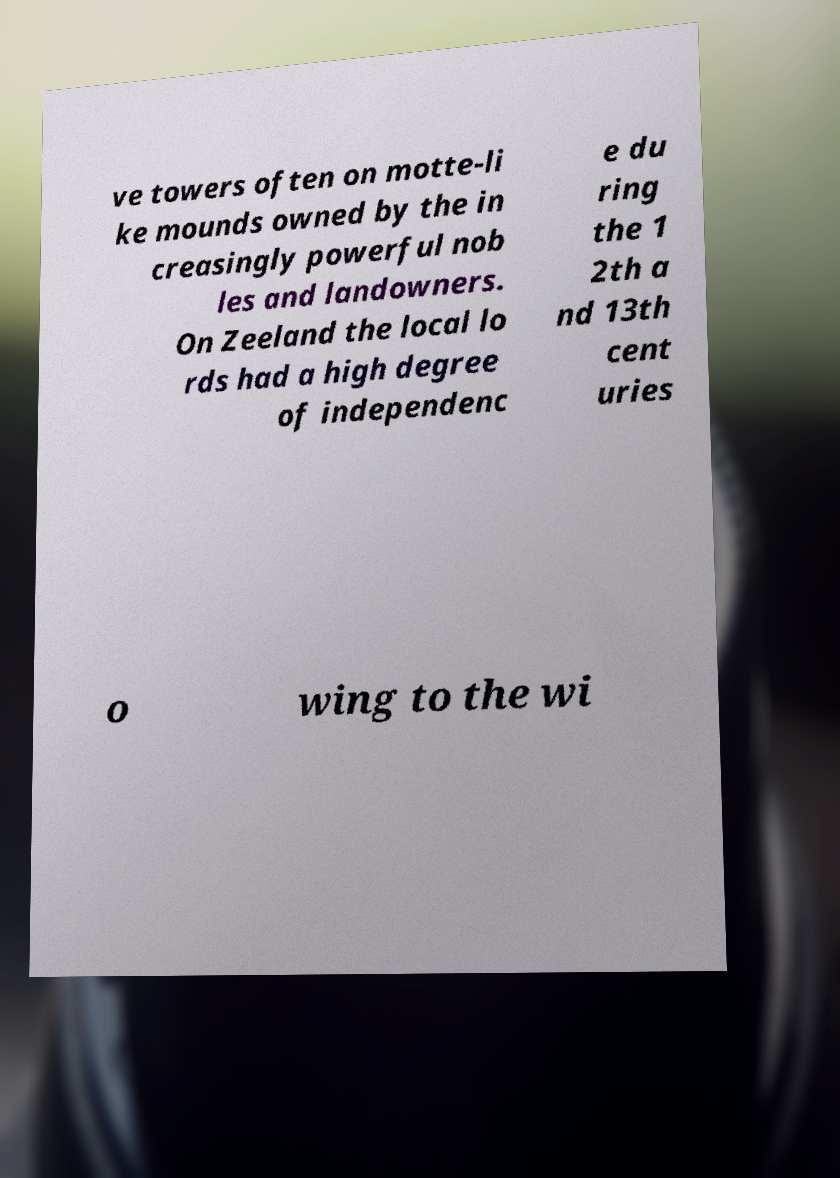Please read and relay the text visible in this image. What does it say? ve towers often on motte-li ke mounds owned by the in creasingly powerful nob les and landowners. On Zeeland the local lo rds had a high degree of independenc e du ring the 1 2th a nd 13th cent uries o wing to the wi 